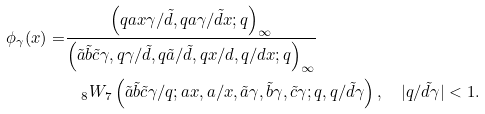Convert formula to latex. <formula><loc_0><loc_0><loc_500><loc_500>\phi _ { \gamma } ( x ) = & \frac { \left ( q a x \gamma / \tilde { d } , q a \gamma / \tilde { d } x ; q \right ) _ { \infty } } { \left ( \tilde { a } \tilde { b } \tilde { c } \gamma , q \gamma / \tilde { d } , q \tilde { a } / \tilde { d } , q x / d , q / d x ; q \right ) _ { \infty } } \\ & \quad _ { 8 } W _ { 7 } \left ( \tilde { a } \tilde { b } \tilde { c } \gamma / q ; a x , a / x , \tilde { a } \gamma , \tilde { b } \gamma , \tilde { c } \gamma ; q , q / \tilde { d } \gamma \right ) , \quad | q / \tilde { d } \gamma | < 1 .</formula> 